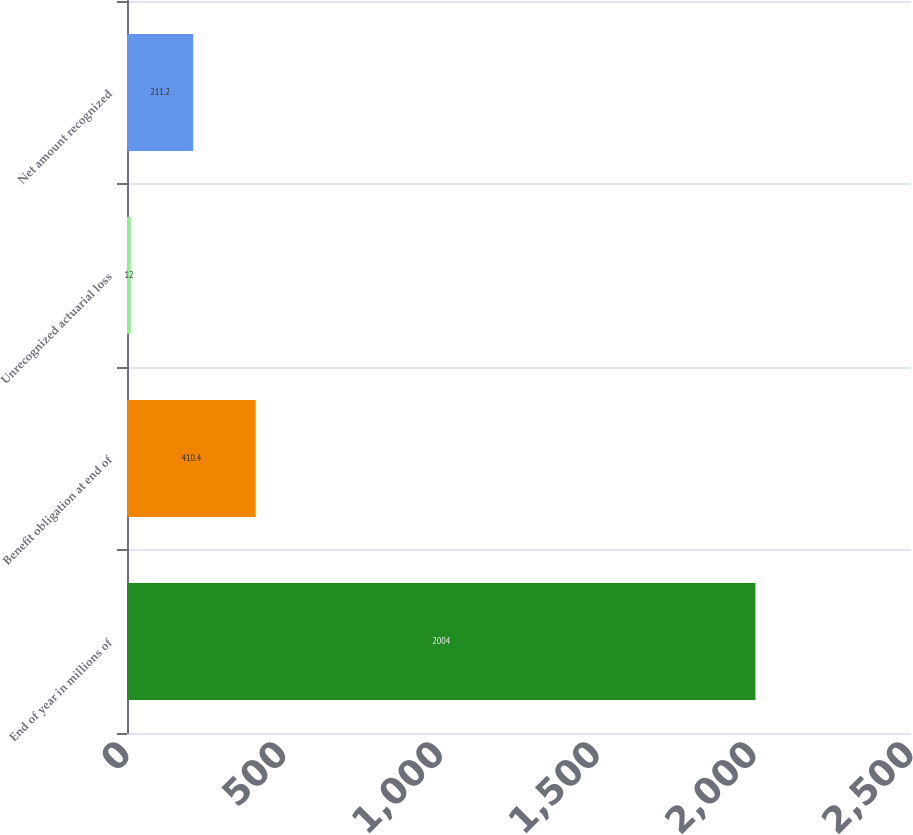Convert chart. <chart><loc_0><loc_0><loc_500><loc_500><bar_chart><fcel>End of year in millions of<fcel>Benefit obligation at end of<fcel>Unrecognized actuarial loss<fcel>Net amount recognized<nl><fcel>2004<fcel>410.4<fcel>12<fcel>211.2<nl></chart> 